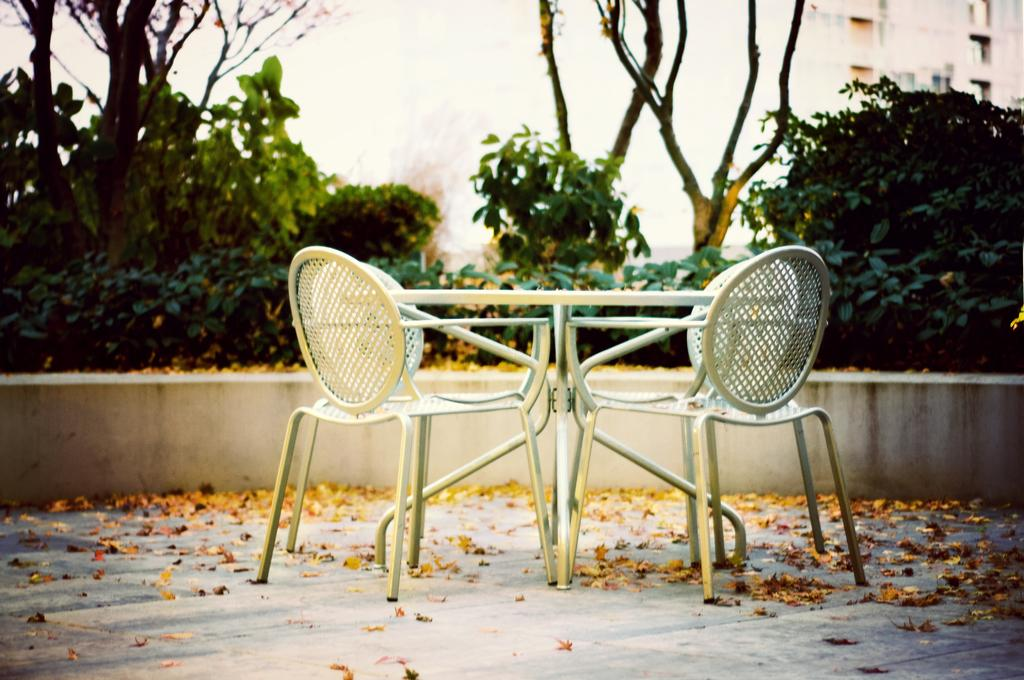What is located in the foreground of the image? There is a table and chairs in the foreground of the image. What can be seen on the ground in the image? Dried leaves are present on the ground. What is visible in the background of the image? There are trees and buildings in the background of the image. What time of day is it in the image, as indicated by the presence of the bucket? There is no bucket present in the image, so we cannot determine the time of day based on that. 